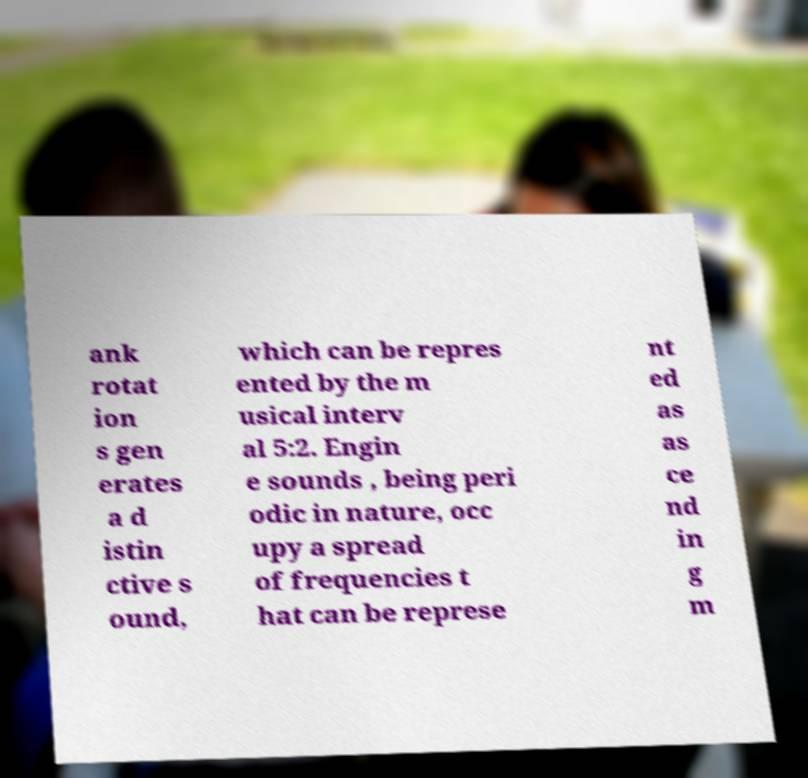For documentation purposes, I need the text within this image transcribed. Could you provide that? ank rotat ion s gen erates a d istin ctive s ound, which can be repres ented by the m usical interv al 5:2. Engin e sounds , being peri odic in nature, occ upy a spread of frequencies t hat can be represe nt ed as as ce nd in g m 